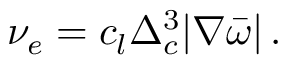<formula> <loc_0><loc_0><loc_500><loc_500>\nu _ { e } = c _ { l } \Delta _ { c } ^ { 3 } | \nabla \bar { \omega } | \, .</formula> 